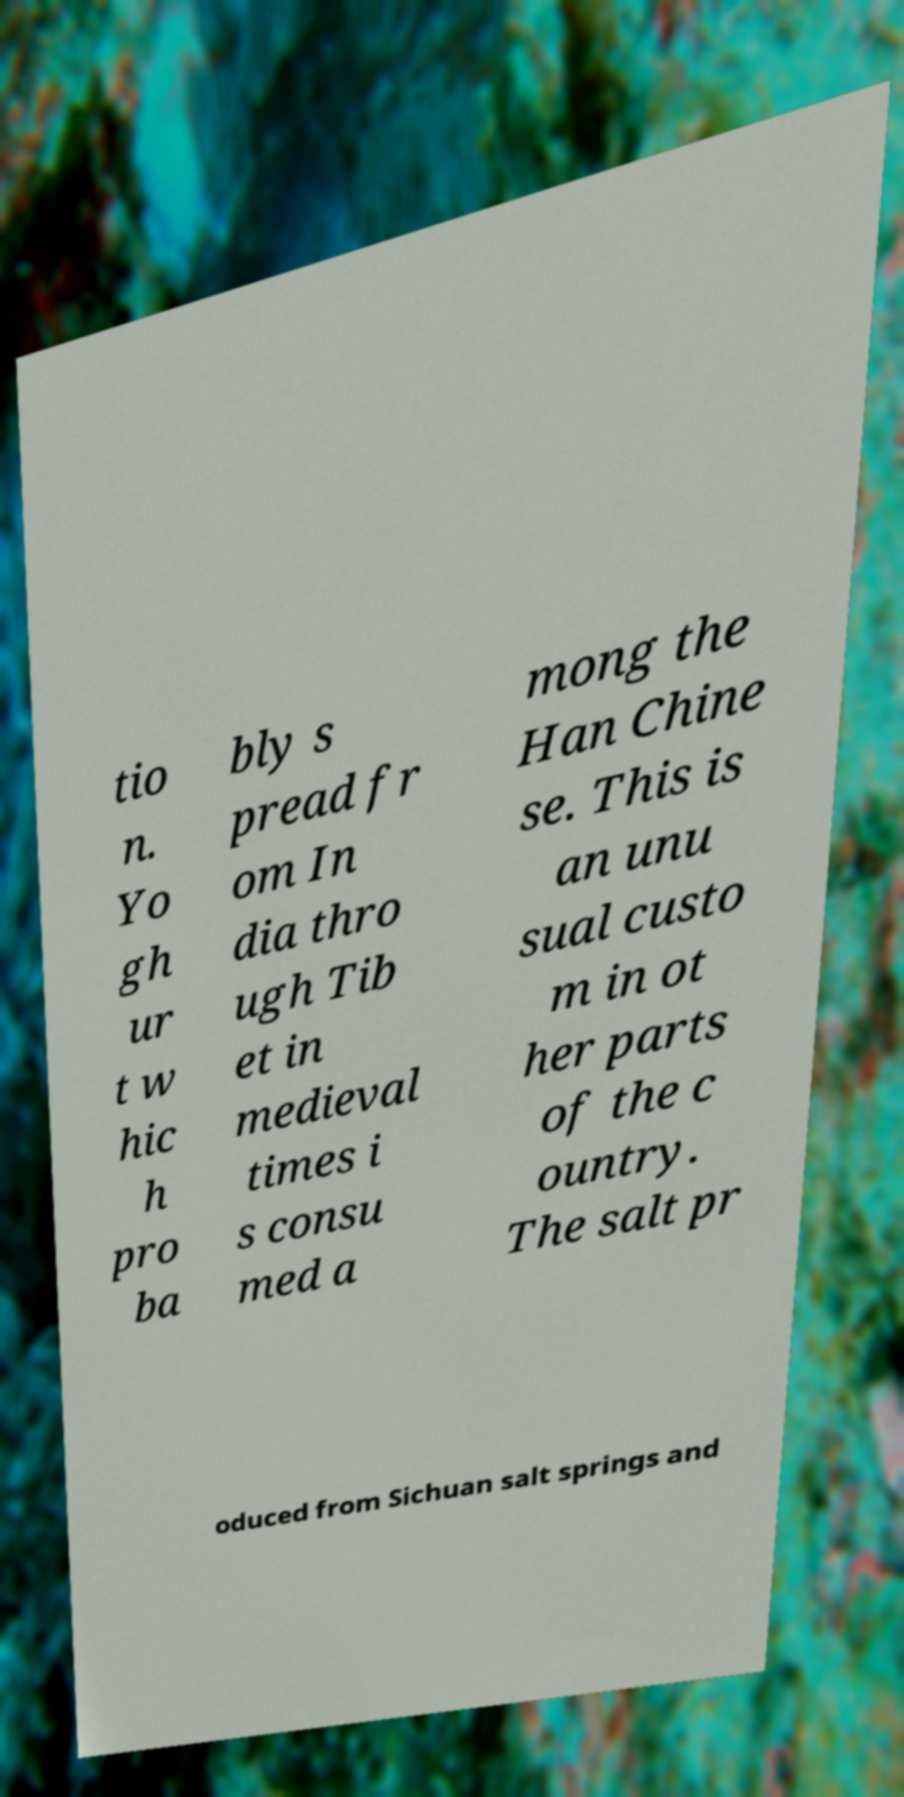What messages or text are displayed in this image? I need them in a readable, typed format. tio n. Yo gh ur t w hic h pro ba bly s pread fr om In dia thro ugh Tib et in medieval times i s consu med a mong the Han Chine se. This is an unu sual custo m in ot her parts of the c ountry. The salt pr oduced from Sichuan salt springs and 